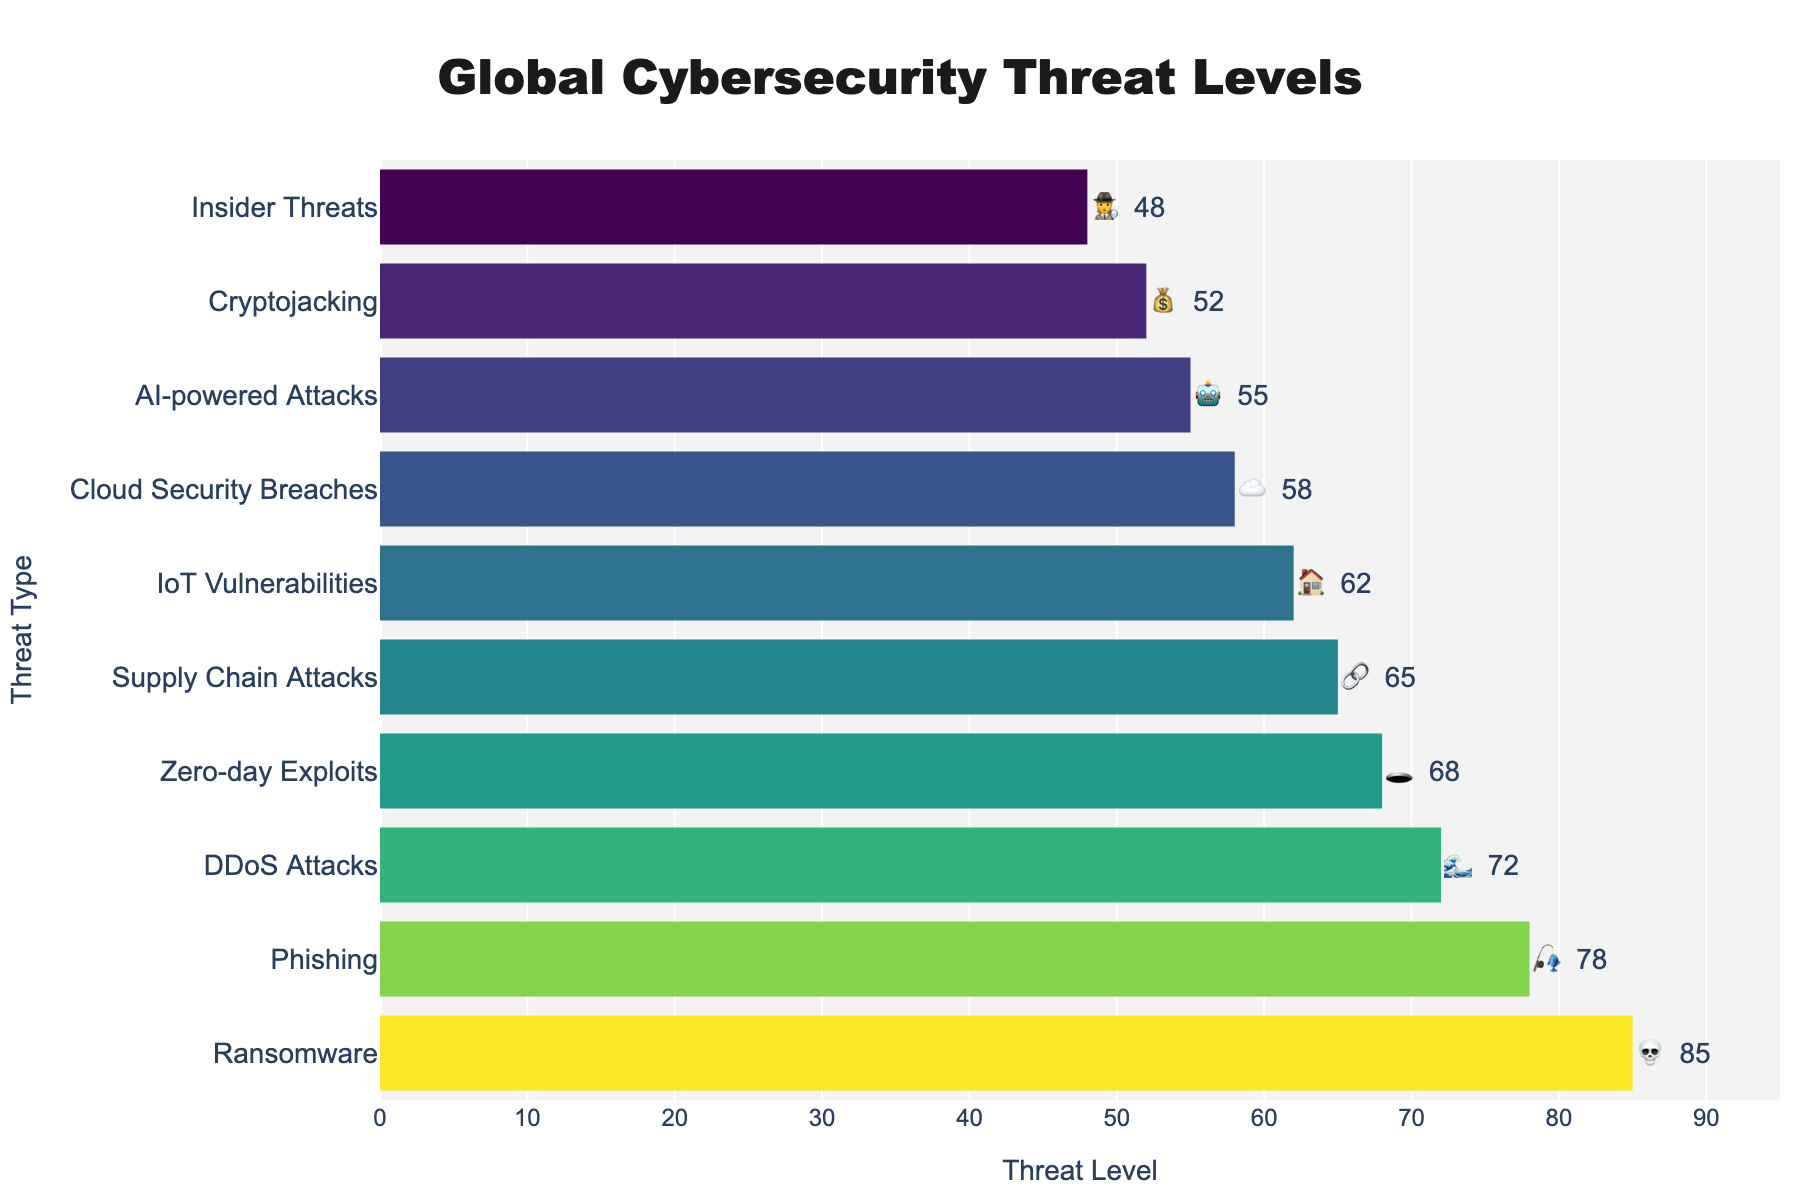What's the title of the chart? The title of the chart is displayed at the top center of the figure.
Answer: Global Cybersecurity Threat Levels What is the range of the x-axis? The x-axis range is defined by the lowest and highest global threat levels plus a buffer. In this case, it ranges from 0 to slightly above 85.
Answer: 0 to 95 Which threat type has the highest global threat level? Look for the longest bar, which corresponds to the highest global threat level.
Answer: Ransomware How many threat types have a global threat level above 70? Count the number of bars with values greater than 70.
Answer: 3 Which threat type is symbolized with a moon emoji? Observe the text indicators next to the bars to find the moon emoji.
Answer: Zero-day Exploits What is the average global threat level of the top 3 threat types? Sum the highest three global threat levels and divide by 3: (85 + 78 + 72) / 3.
Answer: 78.33 What is the difference in global threat level between Phishing and IoT Vulnerabilities? Subtract the global threat level of IoT Vulnerabilities (62) from Phishing (78).
Answer: 16 Which is higher, Cloud Security Breaches or Cryptojacking? Compare the global threat levels of both: Cloud Security Breaches (58) and Cryptojacking (52).
Answer: Cloud Security Breaches What emoji indicator is used for Insider Threats? Observe the text next to the bar corresponding to Insider Threats.
Answer: 🕵️ Is the global threat level of AI-powered Attacks greater than that of Insider Threats? Compare the global threat levels: AI-powered Attacks (55) and Insider Threats (48).
Answer: Yes 